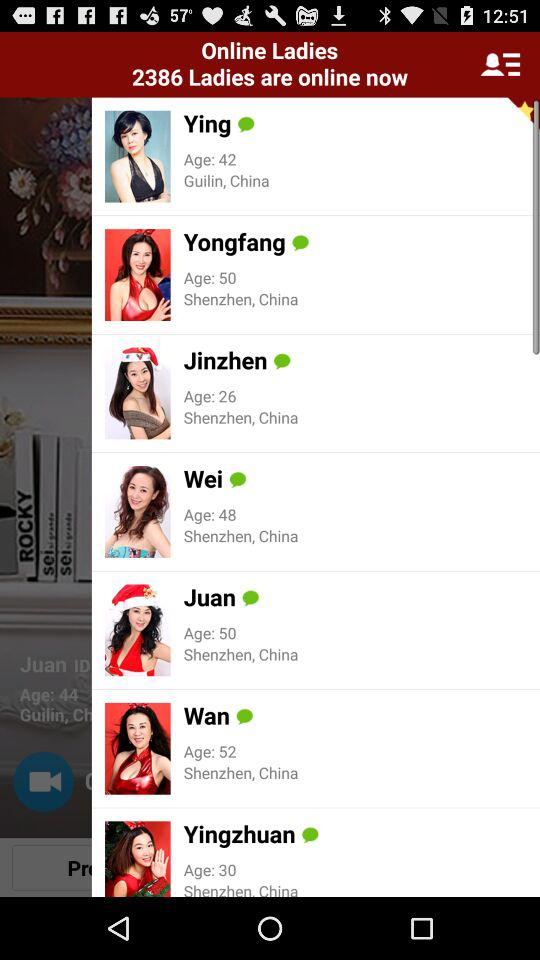What is the age of Ying? Ying is 42 years old. 